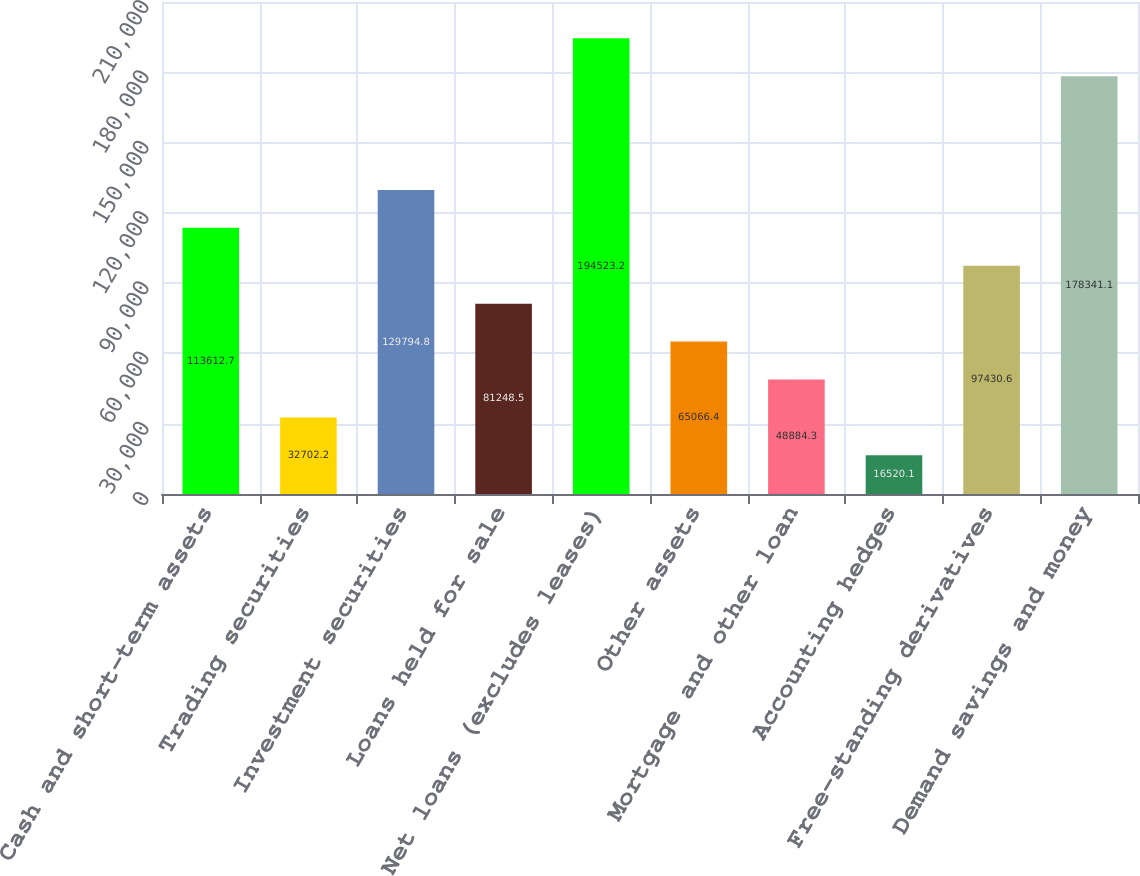Convert chart. <chart><loc_0><loc_0><loc_500><loc_500><bar_chart><fcel>Cash and short-term assets<fcel>Trading securities<fcel>Investment securities<fcel>Loans held for sale<fcel>Net loans (excludes leases)<fcel>Other assets<fcel>Mortgage and other loan<fcel>Accounting hedges<fcel>Free-standing derivatives<fcel>Demand savings and money<nl><fcel>113613<fcel>32702.2<fcel>129795<fcel>81248.5<fcel>194523<fcel>65066.4<fcel>48884.3<fcel>16520.1<fcel>97430.6<fcel>178341<nl></chart> 